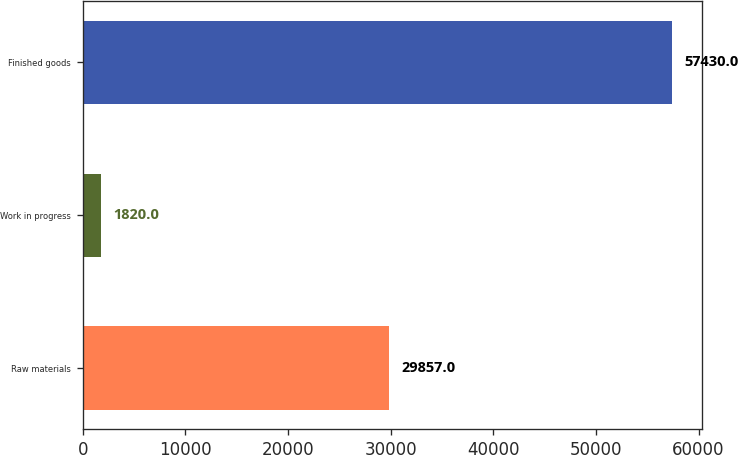Convert chart to OTSL. <chart><loc_0><loc_0><loc_500><loc_500><bar_chart><fcel>Raw materials<fcel>Work in progress<fcel>Finished goods<nl><fcel>29857<fcel>1820<fcel>57430<nl></chart> 